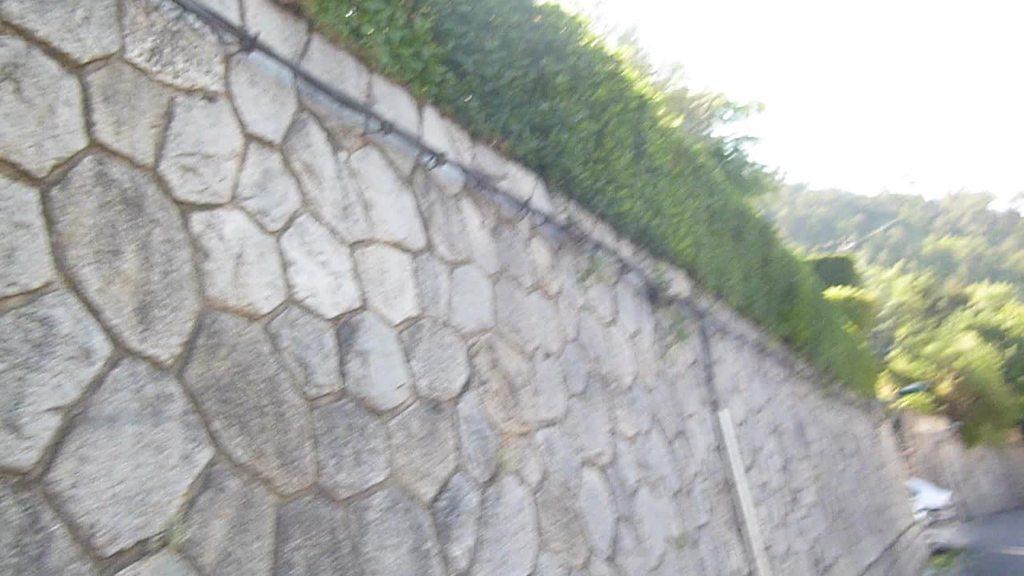Describe this image in one or two sentences. In this picture we can see a wall, plants and trees. 